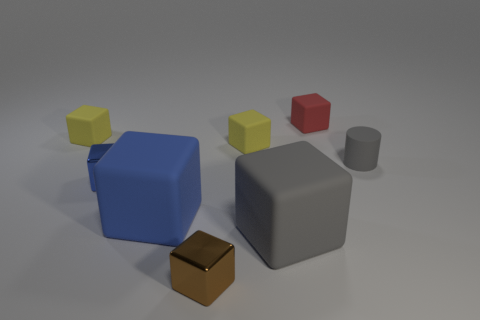Do the brown thing and the gray cube have the same size?
Give a very brief answer. No. What is the color of the small object that is both on the left side of the big blue thing and behind the blue shiny cube?
Provide a short and direct response. Yellow. There is another gray thing that is the same material as the large gray object; what is its shape?
Provide a short and direct response. Cylinder. What number of things are both on the right side of the big gray cube and left of the brown metal block?
Your response must be concise. 0. Are there any big blue rubber things right of the big blue matte object?
Ensure brevity in your answer.  No. Is the shape of the gray thing that is behind the big blue rubber cube the same as the gray object on the left side of the red thing?
Your answer should be very brief. No. What number of things are cylinders or tiny yellow objects that are left of the brown cube?
Ensure brevity in your answer.  2. What number of other things are the same shape as the red matte object?
Your answer should be compact. 6. Are the gray thing that is in front of the gray matte cylinder and the small red object made of the same material?
Offer a very short reply. Yes. How many things are small purple objects or brown cubes?
Your response must be concise. 1. 